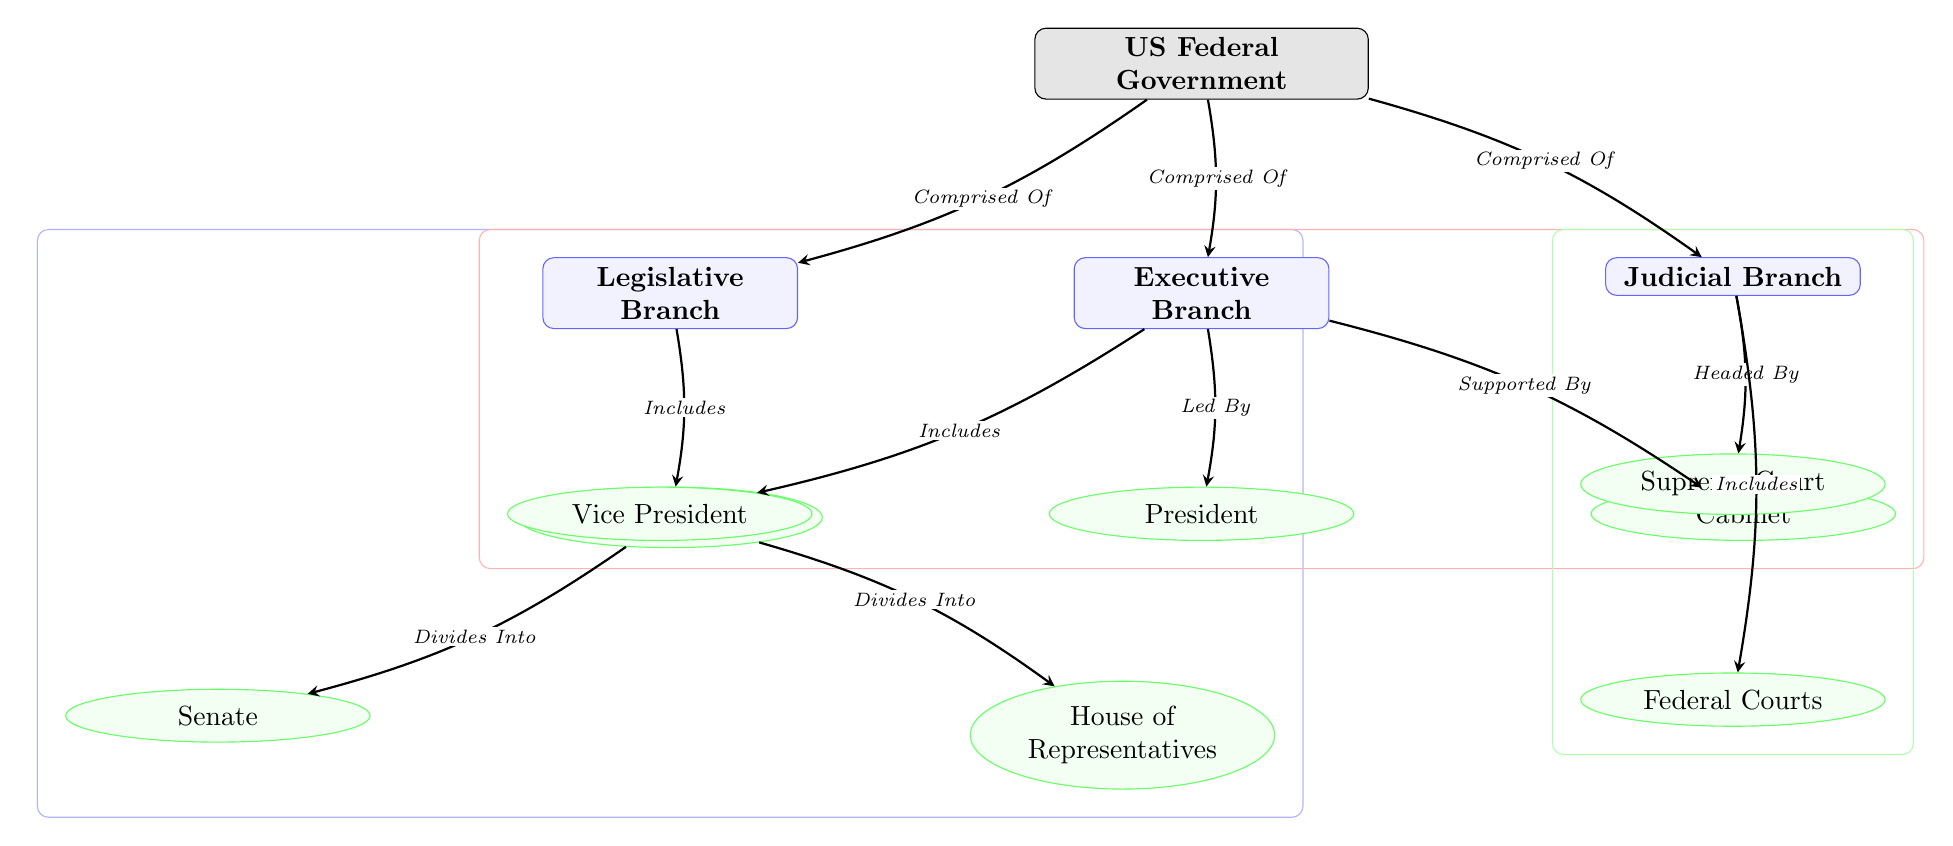What are the three branches of the US Federal Government? The diagram clearly shows three branches labeled as Legislative Branch, Executive Branch, and Judicial Branch, indicating these are the main divisions of the US Federal Government.
Answer: Legislative Branch, Executive Branch, Judicial Branch Who leads the Executive Branch? According to the diagram, the arrow labeled "Led By" points from the Executive Branch to the President, indicating that the President is the leader of the Executive Branch.
Answer: President How many entities are part of Congress? The diagram depicts Congress as comprising two entities: the Senate and the House of Representatives, which are directly connected to Congress via arrows labeled "Divides Into."
Answer: 2 What is the relationship between the Judicial Branch and the Supreme Court? The diagram illustrates that the Judicial Branch is "Headed By" the Supreme Court, indicating a direct leadership relationship between these two components.
Answer: Headed By What is included in the Executive Branch alongside the President? The diagram shows that the Executive Branch includes both the Vice President and the Cabinet, indicating their inclusion in this branch.
Answer: Vice President, Cabinet Which branch is depicted with a green background? The branch that is shown with a green background in the diagram is the Judicial Branch, identified by the surrounding fit node drawn in green.
Answer: Judicial Branch What is the primary purpose of the arrows in the diagram? The arrows connect the various nodes and indicate the relationship types between them, such as "Comprised Of," "Includes," and "Divides Into," clarifying how the components relate to one another.
Answer: Indicate relationships How many total nodes are represented in the diagram? By counting all the nodes in the diagram, including the main branches and their respective entities, we find a total of 8 nodes (1 root, 3 branches, and 4 entities).
Answer: 8 What color is used for the Legislative Branch? The Legislative Branch is shown in blue with a light fill color, as indicated in the diagram’s style.
Answer: Blue 